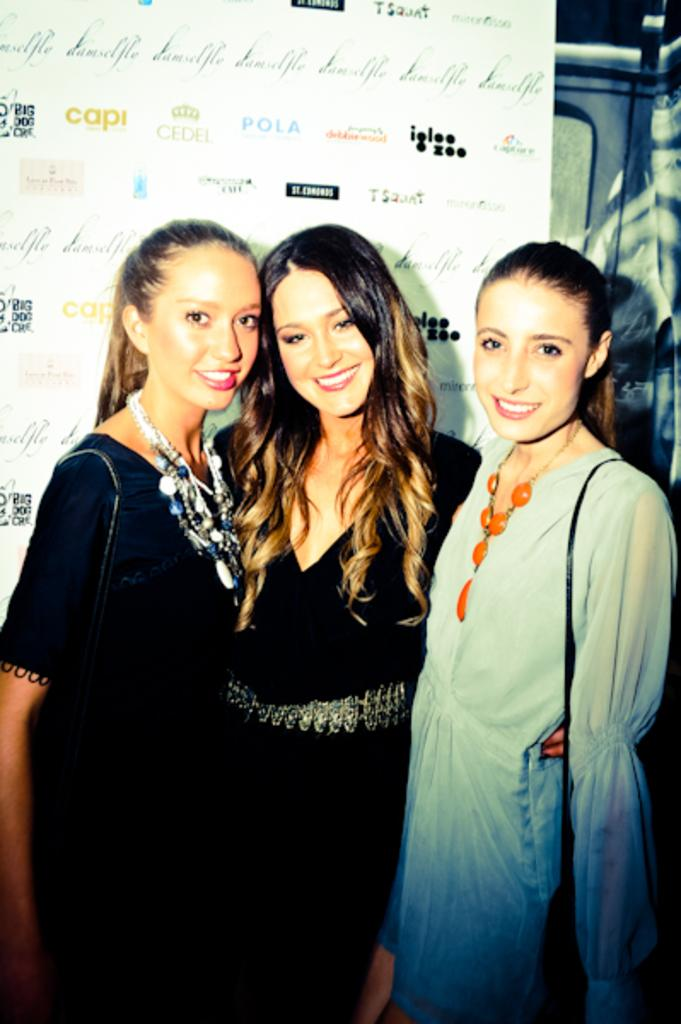How many girls are present in the image? There are three girls in the image. What is the facial expression of the girls? The girls are smiling. What can be seen in the background of the image? There is a banner with text in the background. Can you describe the possible setting or occasion for the image? The image might have been taken at a program or event. What type of punishment is being administered to the girls in the image? There is no indication of punishment in the image; the girls are smiling and there is a banner with text in the background, which suggests a more positive or celebratory setting. 